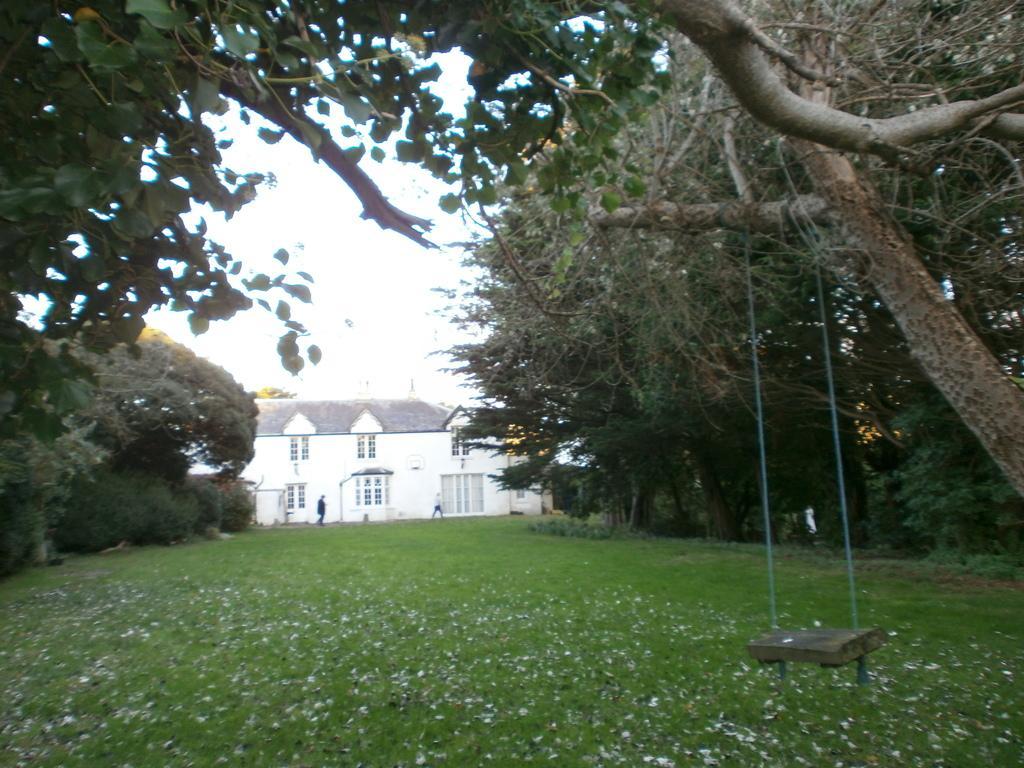How would you summarize this image in a sentence or two? Here we can see a swing, grass, house, trees, and two persons. In the background there is sky. 